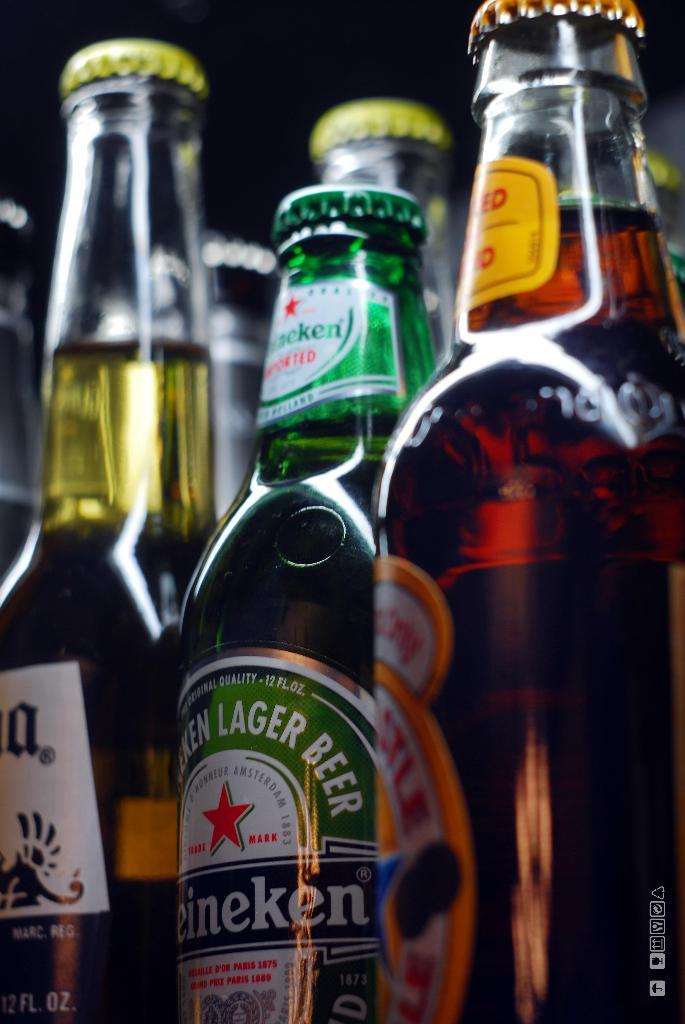<image>
Render a clear and concise summary of the photo. many beers are lined up in rows, including a Heineken 